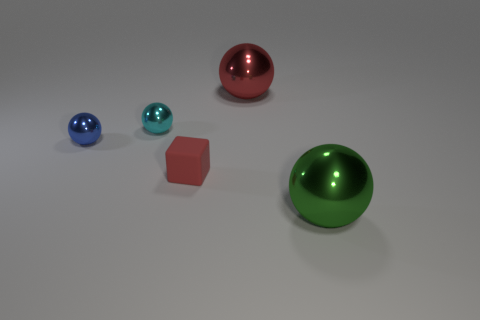Add 4 red balls. How many objects exist? 9 Subtract 1 balls. How many balls are left? 3 Subtract all spheres. How many objects are left? 1 Subtract all red spheres. How many spheres are left? 3 Subtract all brown balls. Subtract all red blocks. How many balls are left? 4 Subtract all blue blocks. How many green spheres are left? 1 Subtract all blue shiny objects. Subtract all green things. How many objects are left? 3 Add 3 large green metal objects. How many large green metal objects are left? 4 Add 2 tiny cyan objects. How many tiny cyan objects exist? 3 Subtract 0 brown cubes. How many objects are left? 5 